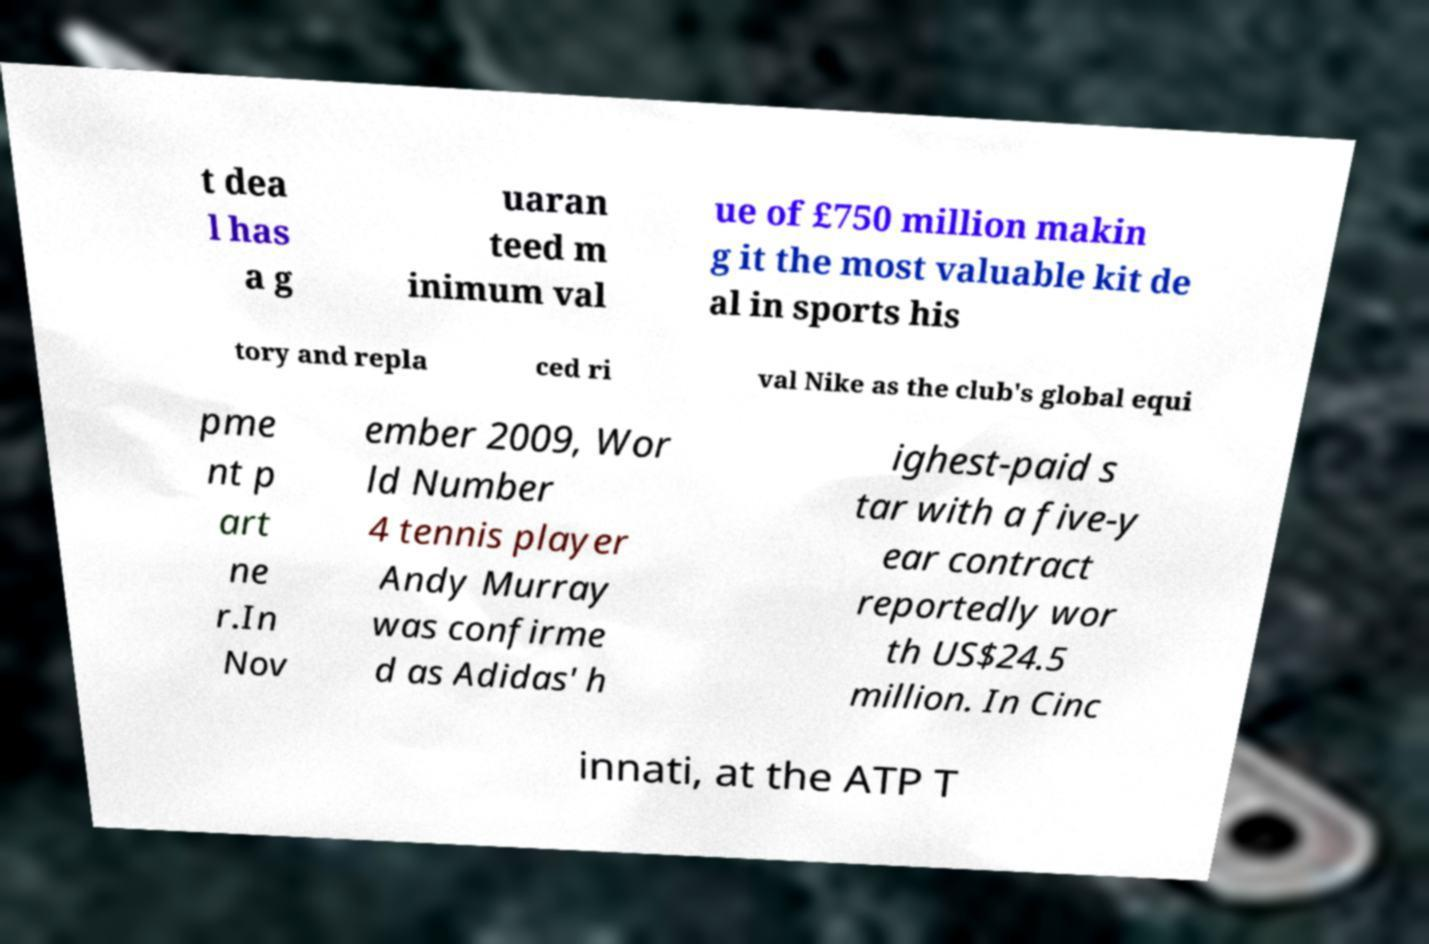Could you extract and type out the text from this image? t dea l has a g uaran teed m inimum val ue of £750 million makin g it the most valuable kit de al in sports his tory and repla ced ri val Nike as the club's global equi pme nt p art ne r.In Nov ember 2009, Wor ld Number 4 tennis player Andy Murray was confirme d as Adidas' h ighest-paid s tar with a five-y ear contract reportedly wor th US$24.5 million. In Cinc innati, at the ATP T 